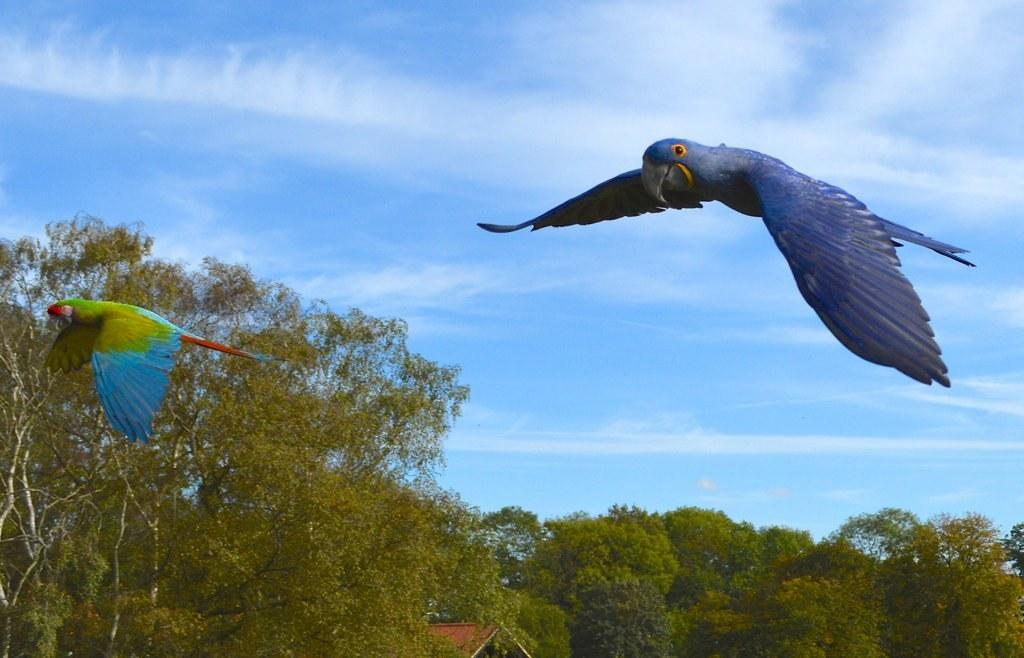What is happening in the sky in the image? There are birds flying in the air in the image. What can be seen behind the birds in the image? There are many trees behind the birds. What type of structure is visible in the image? There is a roof visible in the image. What is the condition of the sky in the image? The sky with clouds is visible at the top of the image. What type of yoke is being used by the birds in the image? There is no yoke present in the image, as birds do not use yokes to fly. 